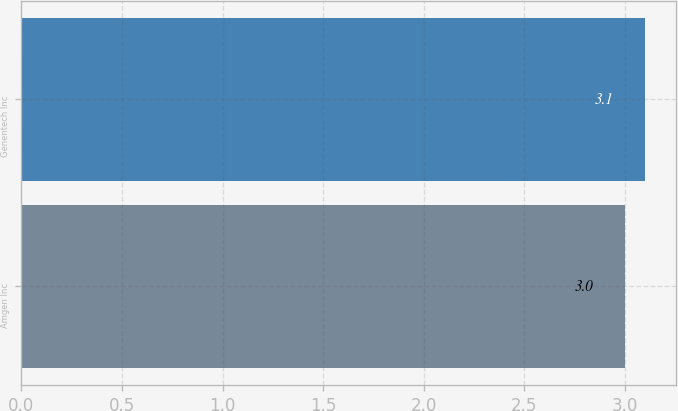Convert chart to OTSL. <chart><loc_0><loc_0><loc_500><loc_500><bar_chart><fcel>Amgen Inc<fcel>Genentech Inc<nl><fcel>3<fcel>3.1<nl></chart> 